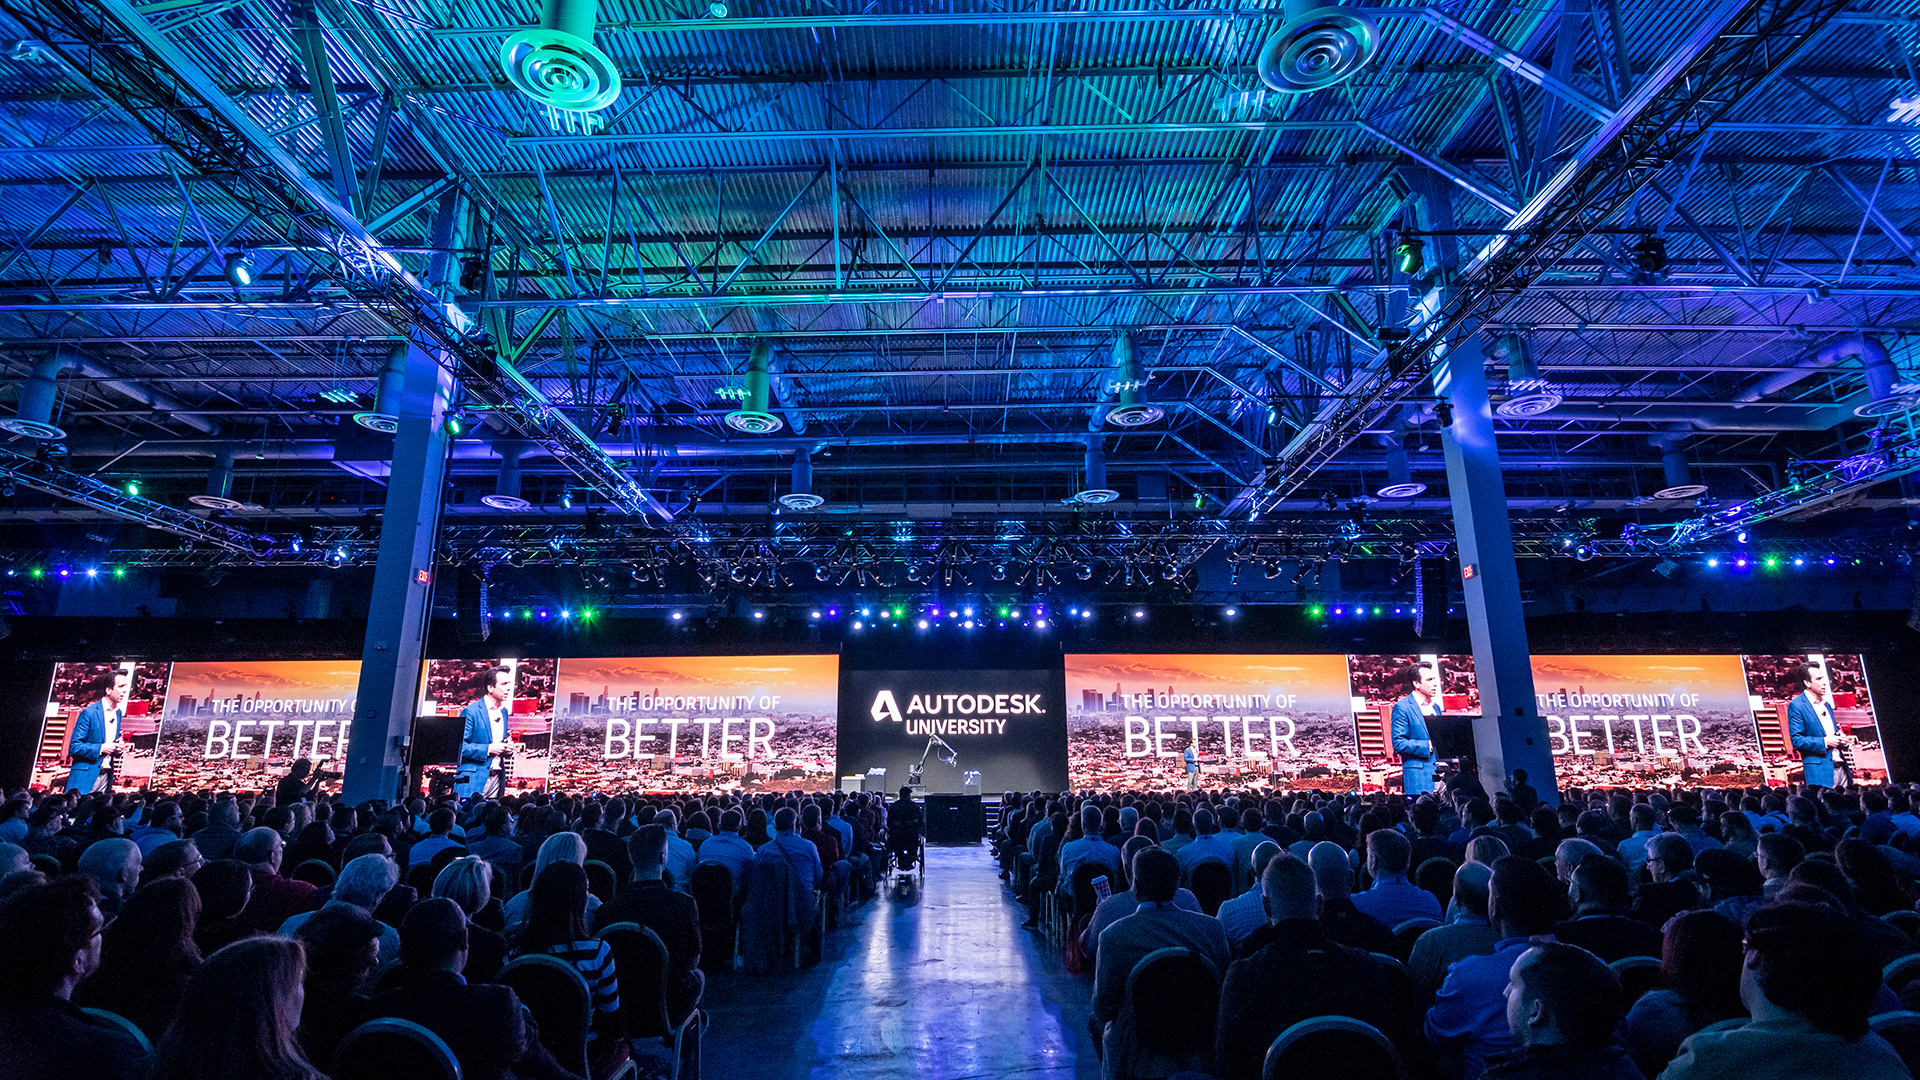From a realistic perspective, how might this event impact the local economy? Events like Autodesk University often have a positive impact on the local economy. They attract a large number of attendees, including professionals, exhibitors, and speakers, who spend money on accommodations, food, transportation, and entertainment. Local businesses, especially those in the hospitality and tourism sectors, benefit from the influx of visitors. Additionally, such events can elevate the city's profile as a hub for conferences and professional gatherings, potentially leading to future events and further economic benefits. Moreover, partnerships with local vendors and service providers could foster business opportunities and contribute to the overall economic development of the area. What are some potential short-term and long-term economic impacts? In the short term, the influx of attendees boosts local spending in hotels, restaurants, and transportation, providing an immediate economic lift. This increased demand can also lead to temporary job creation in various service sectors. In the long term, the event can contribute to the city's reputation as a prime location for large-scale conferences, attracting future events and regular professional gatherings, which sustain economic benefits over time. Long-lasting relationships and partnerships formed at such events can spur investment and development in local industries. Additionally, the event can inspire local companies to innovate and adopt new technologies showcased at the conference, leading to increased efficiency and potential growth. 